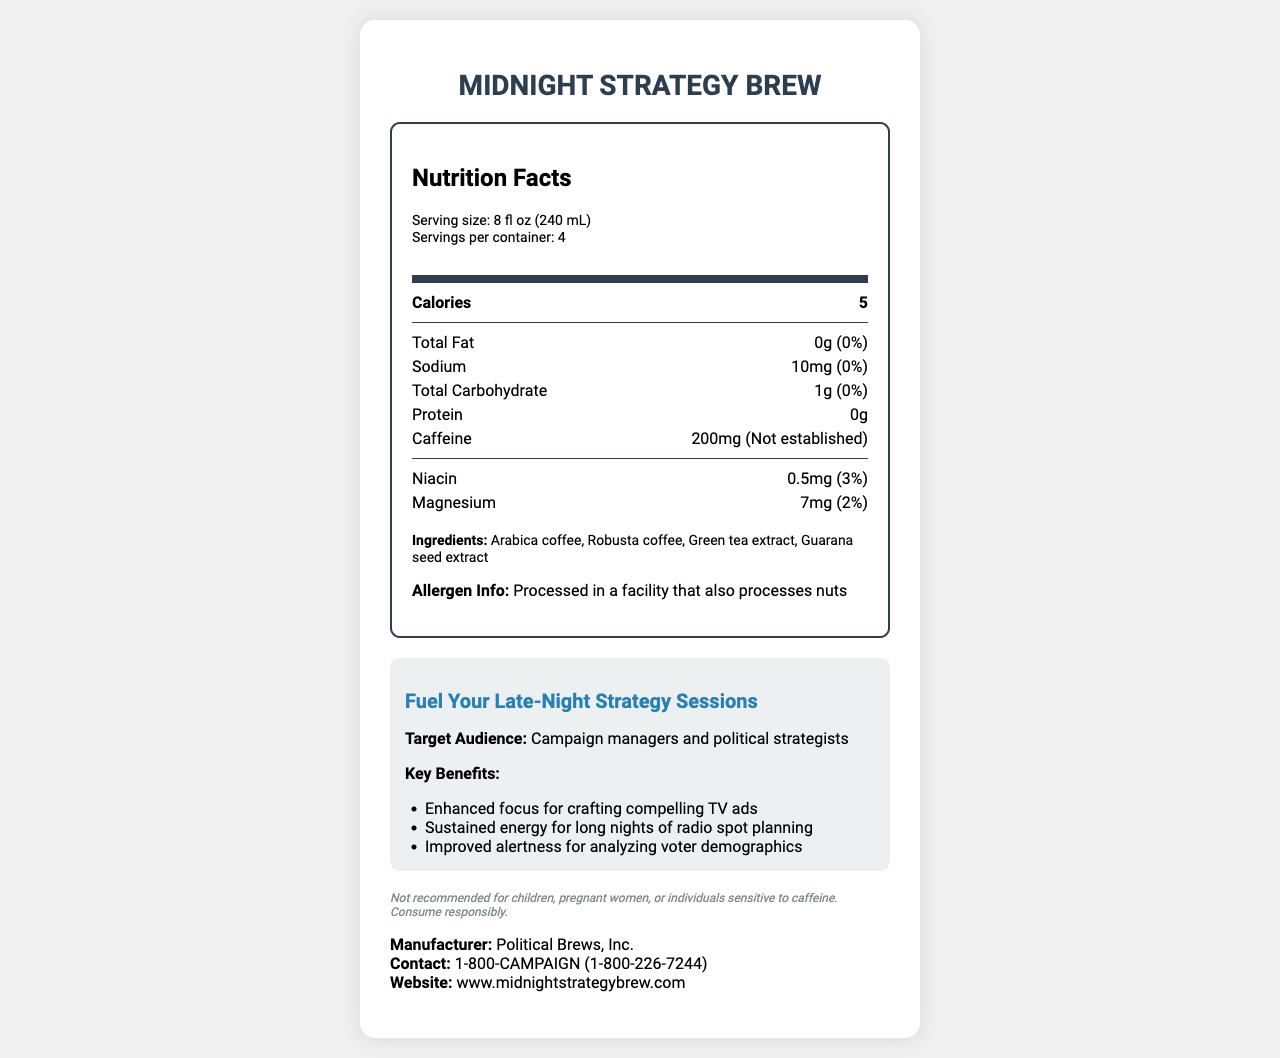what is the serving size of Midnight Strategy Brew? The serving size is specified at the beginning of the Nutrition Facts label under "Serving size."
Answer: 8 fl oz (240 mL) how many calories are there per serving? The number of calories per serving is listed under the "Calories" section in the Nutrition Facts label.
Answer: 5 what is the total carbohydrate content in a serving? The total carbohydrate content is shown with its daily value percentage next to it under the "Total Carbohydrate" section in the Nutrition Facts label.
Answer: 1g (0%) how much caffeine is in each serving? The amount of caffeine per serving is specified under the "Caffeine" section in the Nutrition Facts label.
Answer: 200mg are there any allergens mentioned for this product? The allergen information is found at the bottom of the Nutrition Facts label under "Allergen Info."
Answer: Processed in a facility that also processes nuts what is the name of the manufacturer? The manufacturer's name is located at the bottom of the document under "Manufacturer."
Answer: Political Brews, Inc. A campaign manager needs a late-night energy boost. Which key benefit of Midnight Strategy Brew would be most relevant to them? A. Enhanced focus for crafting compelling TV ads B. Better sleep quality C. Weight loss The document lists "Enhanced focus for crafting compelling TV ads" as a key benefit specifically relevant to campaign managers.
Answer: A. Enhanced focus for crafting compelling TV ads which one of these ingredients is not part of Midnight Strategy Brew? 1. Arabica coffee 2. Green tea extract 3. Sugar 4. Guarana seed extract The document lists the ingredients as "Arabica coffee, Robusta coffee, Green tea extract, Guarana seed extract," and there is no mention of sugar.
Answer: 3. Sugar can you determine whether Midnight Strategy Brew is safe for children? The disclaimer states "Not recommended for children," indicating it's not intended for them.
Answer: No describe the main idea of the document. The document focuses on providing detailed nutrition facts relevant to a caffeine-rich coffee blend, specifically targeting campaign managers and strategists, and highlights its benefits and usage warnings.
Answer: Midnight Strategy Brew is a caffeine-rich coffee blend tailored for campaign managers and political strategists engaging in late-night sessions. The label provides extensive nutrition details, emphasizing low calories, high caffeine content, and key benefits for focus and energy. how much protein does Midnight Strategy Brew contain per serving? The protein content per serving is listed as "0g" in the Nutrition Facts label.
Answer: 0g what is the contact information for queries related to Midnight Strategy Brew? The contact information for the manufacturer is at the bottom of the document under "Contact."
Answer: 1-800-CAMPAIGN (1-800-226-7244) how many servings are there in one container? The number of servings per container is listed at the beginning of the Nutrition Facts label under "Servings per container."
Answer: 4 which vitamin has the highest daily value percentage in Midnight Strategy Brew? Under the vitamins and minerals section, Niacin is listed with a 3% daily value, which is higher than Magnesium's 2%.
Answer: Niacin (3%) is Midnight Strategy Brew recommended for pregnant women? The disclaimer advises that the product is "Not recommended for... pregnant women."
Answer: No how much magnesium is there in a serving? The magnesium content per serving is listed under the vitamins and minerals section as "7mg (2%)."
Answer: 7mg (2%) what vitamins and minerals are included in Midnight Strategy Brew? The vitamins and minerals section lists Niacin and Magnesium with their respective amounts and daily values.
Answer: Niacin and Magnesium which key benefit is not listed for Midnight Strategy Brew? A. Enhanced focus for crafting compelling TV ads B. Improved alertness for analyzing voter demographics C. Better sleep quality D. Sustained energy for long nights of radio spot planning The document does not list "Better sleep quality" as a key benefit; it focuses on benefits related to focus and energy.
Answer: C. Better sleep quality how is the slogan for Midnight Strategy Brew phrased? The campaign-specific info section prominently displays the slogan "Fuel Your Late-Night Strategy Sessions."
Answer: Fuel Your Late-Night Strategy Sessions are the nutrients in Midnight Strategy Brew listed as beneficial for weight loss? The document focuses on the content and benefits related to focus, energy, and alertness, without mentioning weight loss.
Answer: Not mentioned 